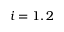<formula> <loc_0><loc_0><loc_500><loc_500>i = 1 , 2</formula> 